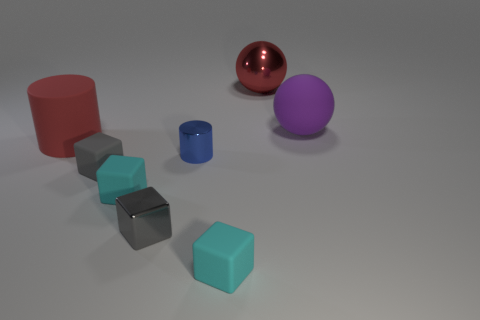What number of other objects are the same shape as the purple matte thing?
Ensure brevity in your answer.  1. Does the cylinder behind the blue thing have the same material as the small cylinder?
Give a very brief answer. No. How many things are either matte balls or large red cubes?
Offer a terse response. 1. What size is the matte object that is the same shape as the large red metal object?
Provide a short and direct response. Large. How big is the metallic sphere?
Ensure brevity in your answer.  Large. Is the number of small blue metallic cylinders to the left of the red metal object greater than the number of small yellow metallic spheres?
Your answer should be compact. Yes. Does the metal thing that is behind the small blue cylinder have the same color as the large rubber object that is left of the large purple thing?
Your answer should be very brief. Yes. What is the material of the big red thing that is in front of the big rubber object to the right of the cyan object in front of the gray shiny thing?
Offer a very short reply. Rubber. Are there more rubber spheres than gray things?
Your answer should be compact. No. Is there any other thing of the same color as the matte cylinder?
Provide a succinct answer. Yes. 